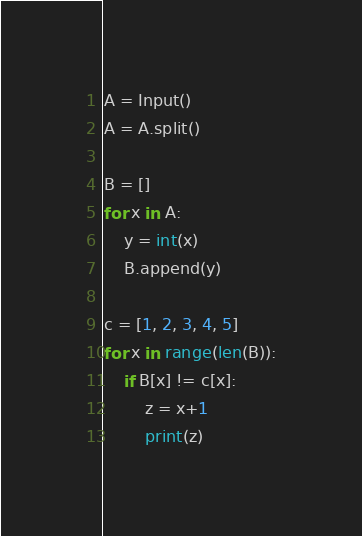<code> <loc_0><loc_0><loc_500><loc_500><_Python_>A = Input()
A = A.split()

B = []
for x in A:
    y = int(x)
    B.append(y)

c = [1, 2, 3, 4, 5]
for x in range(len(B)):
    if B[x] != c[x]:
        z = x+1
        print(z)</code> 